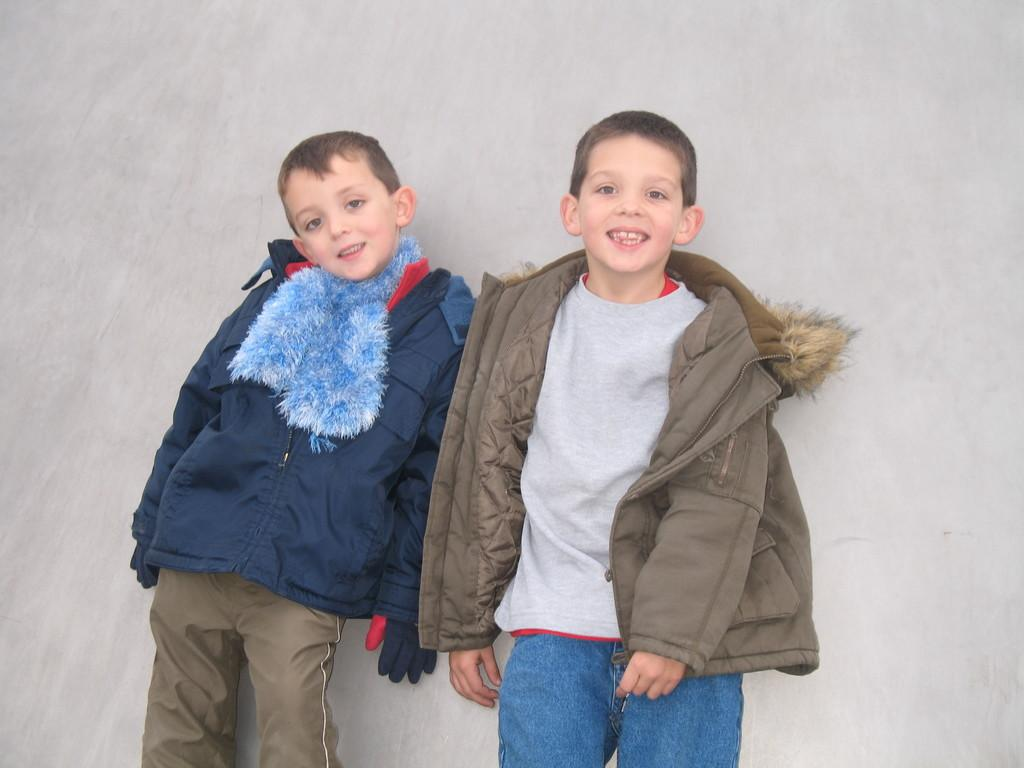How many people are in the image? There are two people in the image. What expressions do the people have on their faces? Both people are wearing smiles on their faces. What can be seen behind the people in the image? There is a wall visible behind the people. What type of hole can be seen in the image? There is no hole present in the image. How many rainstorms are visible in the image? There are no rainstorms visible in the image. 